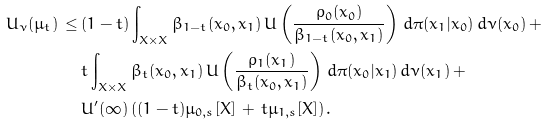Convert formula to latex. <formula><loc_0><loc_0><loc_500><loc_500>U _ { \nu } ( \mu _ { t } ) \, \leq \, & ( 1 - t ) \int _ { X \times X } \beta _ { 1 - t } ( x _ { 0 } , x _ { 1 } ) \, U \left ( \frac { \rho _ { 0 } ( x _ { 0 } ) } { \beta _ { 1 - t } ( x _ { 0 } , x _ { 1 } ) } \right ) \, d \pi ( x _ { 1 } | x _ { 0 } ) \, d \nu ( x _ { 0 } ) \, + \\ & t \int _ { X \times X } \beta _ { t } ( x _ { 0 } , x _ { 1 } ) \, U \left ( \frac { \rho _ { 1 } ( x _ { 1 } ) } { \beta _ { t } ( x _ { 0 } , x _ { 1 } ) } \right ) \, d \pi ( x _ { 0 } | x _ { 1 } ) \, d \nu ( x _ { 1 } ) \, + \\ & U ^ { \prime } ( \infty ) \left ( ( 1 - t ) \mu _ { 0 , s } [ X ] \, + \, t \mu _ { 1 , s } [ X ] \right ) .</formula> 